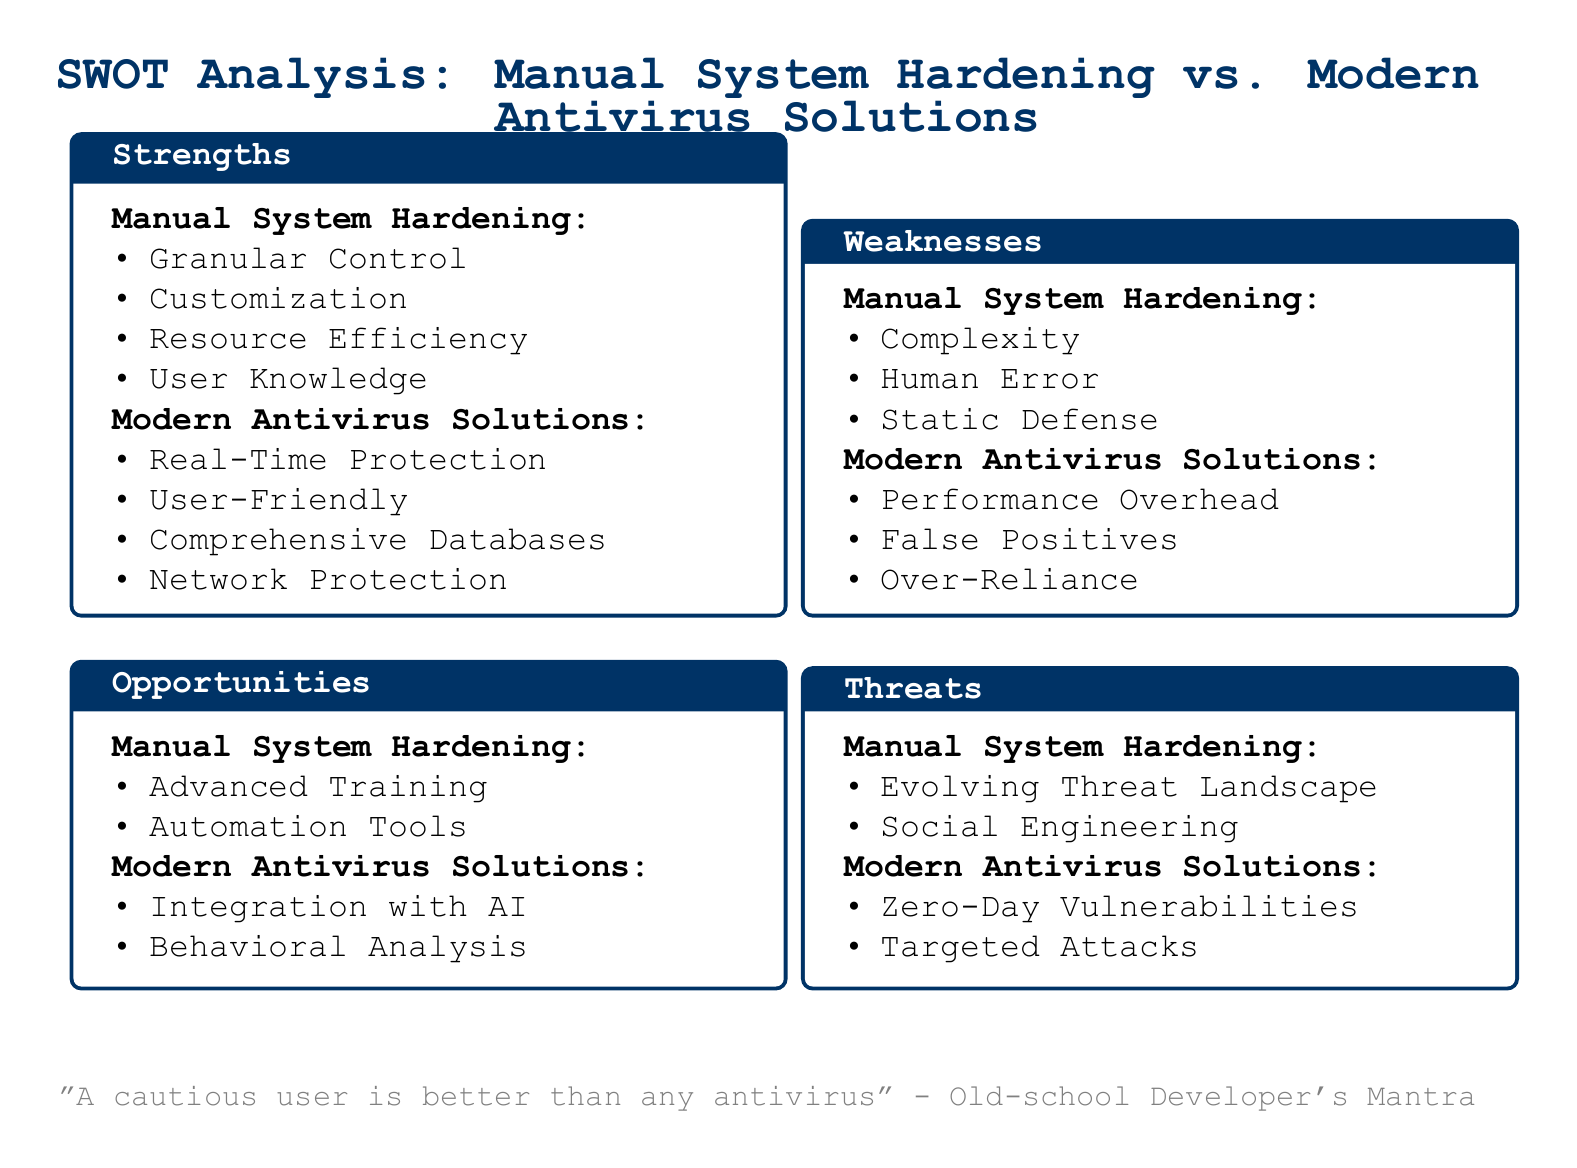What is a strength of manual system hardening? One of the strengths listed for manual system hardening is "Granular Control".
Answer: Granular Control What weakness is associated with modern antivirus solutions? The document lists "Performance Overhead" as a weakness of modern antivirus solutions.
Answer: Performance Overhead What opportunity is mentioned for manual system hardening? "Advanced Training" is identified as an opportunity for manual system hardening.
Answer: Advanced Training What threat does the document highlight for modern antivirus solutions? The document states "Zero-Day Vulnerabilities" as a threat to modern antivirus solutions.
Answer: Zero-Day Vulnerabilities How many strengths are listed for modern antivirus solutions? The document outlines four strengths and the specific strengths are provided.
Answer: Four What is user knowledge categorized under? User knowledge is categorized under the strengths of manual system hardening.
Answer: Strengths Which opportunity relates to modern antivirus solutions? The document states "Integration with AI" as an opportunity related to modern antivirus solutions.
Answer: Integration with AI What is the mantra mentioned at the end of the document? The mantra mentioned is "A cautious user is better than any antivirus".
Answer: A cautious user is better than any antivirus 